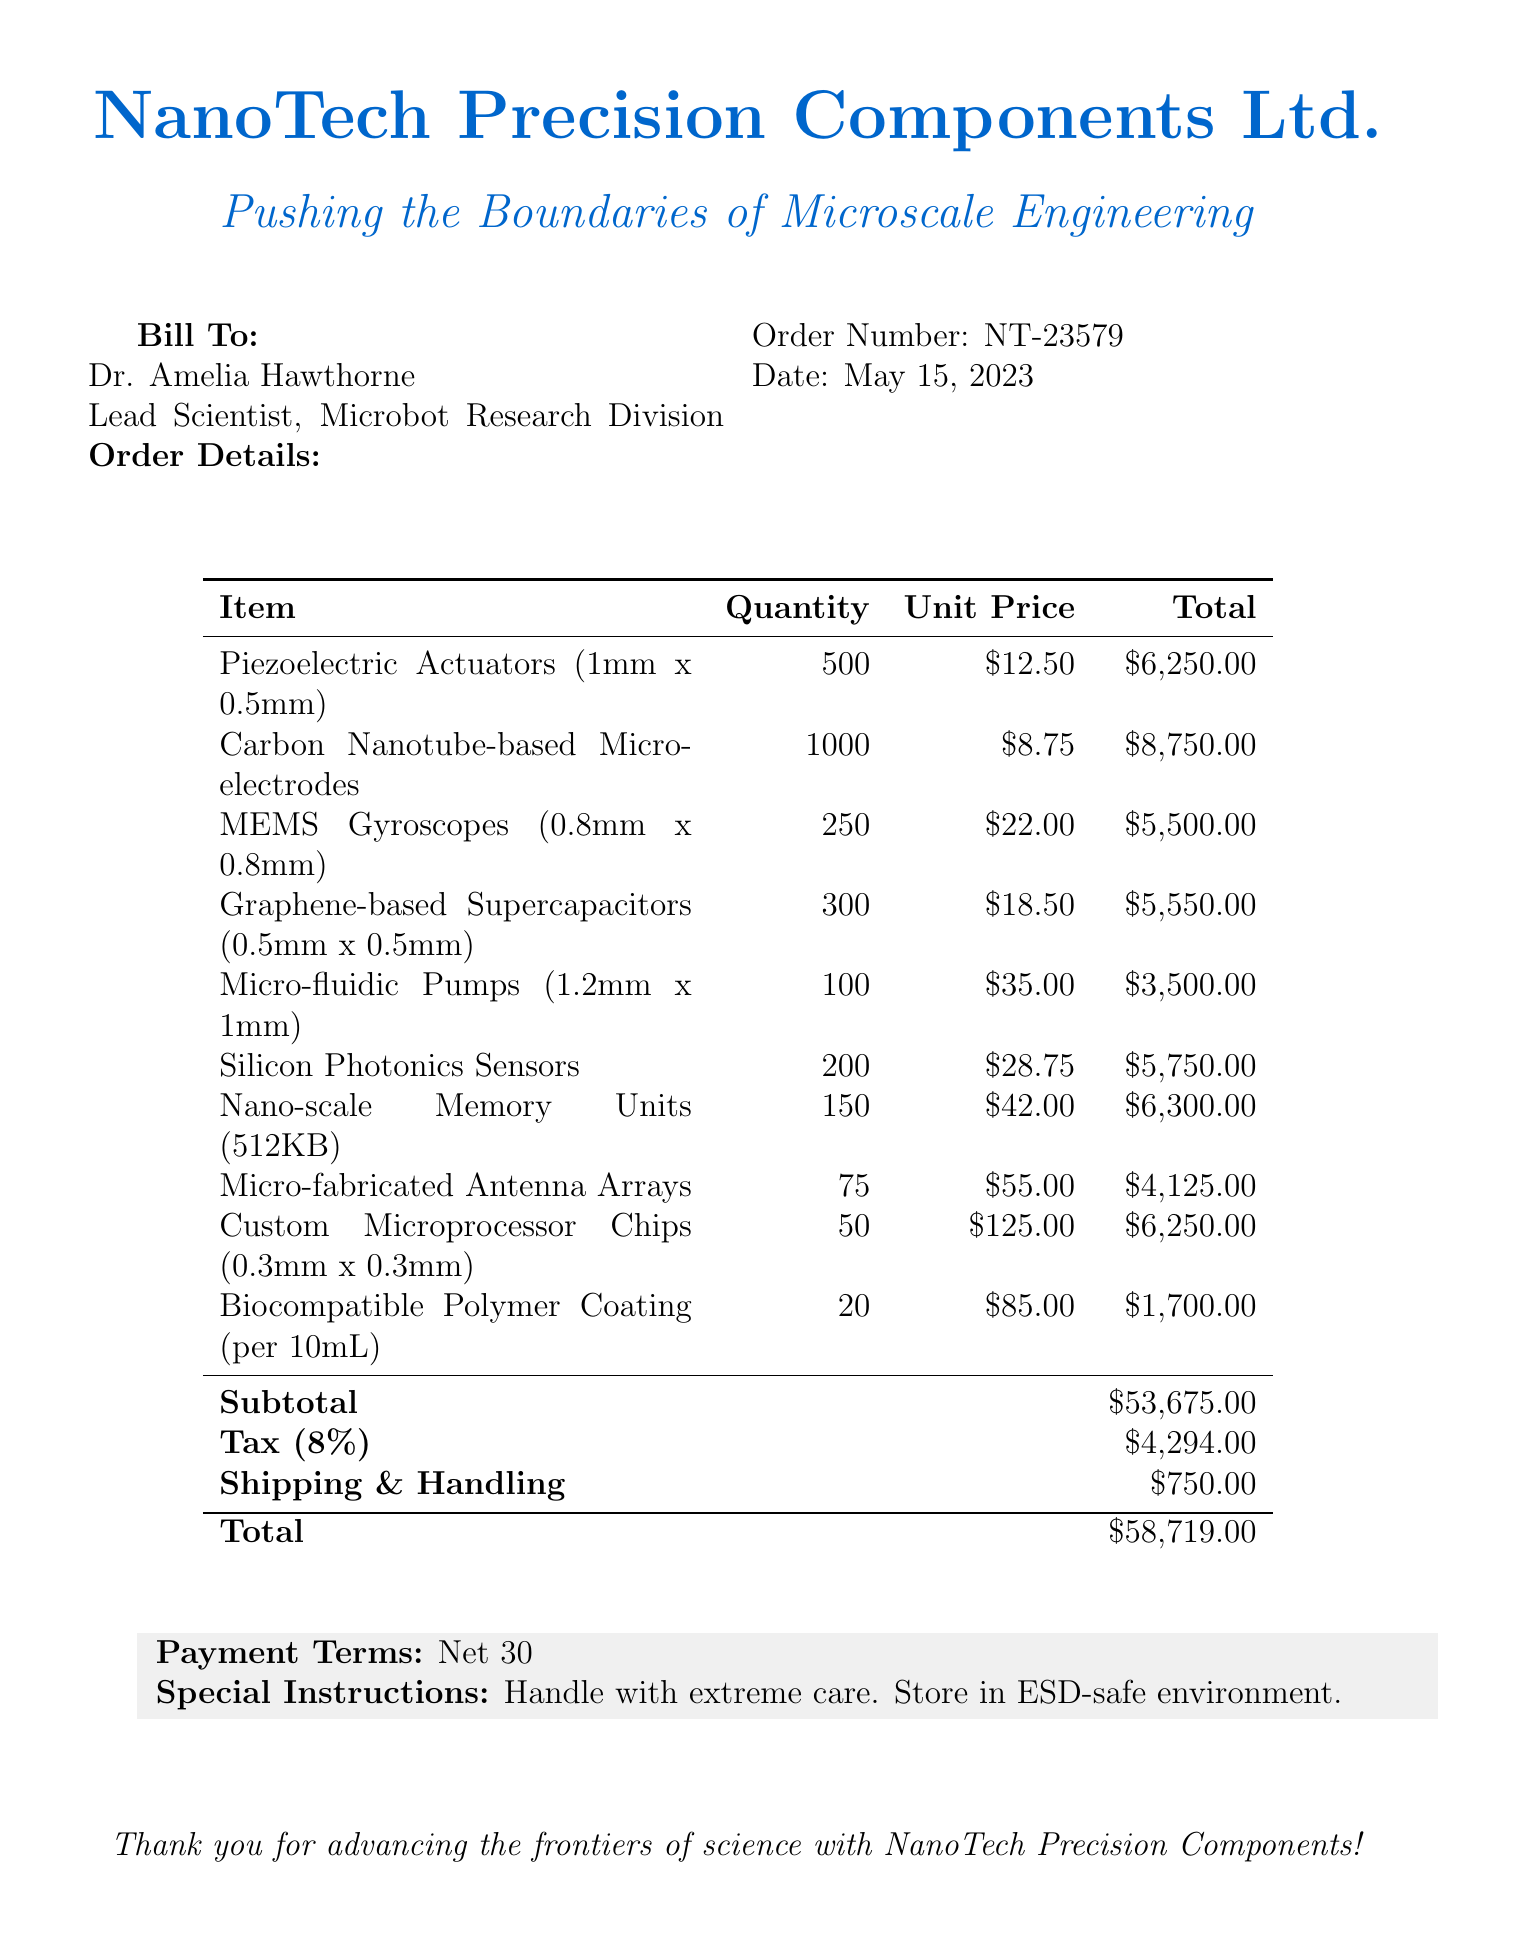what is the supplier name? The supplier name is listed at the top of the document.
Answer: NanoTech Precision Components Ltd who is the customer? The customer's name and title are provided in the bill to section.
Answer: Dr. Amelia Hawthorne what is the order number? The order number is one of the key details included in the document.
Answer: NT-23579 what is the total amount billed? The total amount is calculated and stated at the bottom of the itemized list.
Answer: $58,719.00 how many Piezoelectric Actuators were ordered? The quantity of Piezoelectric Actuators is specified in the items section of the document.
Answer: 500 what is the tax rate on the order? The tax rate is mentioned under the financial details section of the document.
Answer: 8% what is the subtotal before tax and shipping? The subtotal is calculated from all items listed before tax and shipping fees are added.
Answer: $53,675.00 what special instructions are provided? The special instructions are included at the end of the document under payment terms.
Answer: Handle with extreme care. Store in ESD-safe environment how many Micro-fluidic Pumps were ordered? The quantity of Micro-fluidic Pumps is detailed in the itemized list.
Answer: 100 what is the payment term specified in the document? The payment terms are stated in the financial details section.
Answer: Net 30 